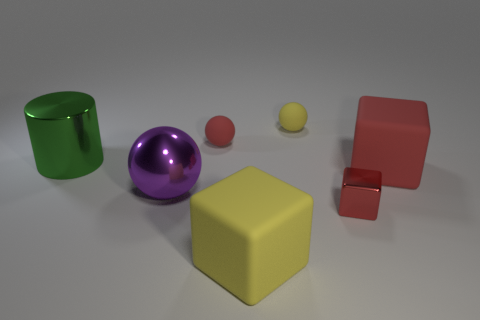There is a cube that is the same material as the big red object; what is its size?
Keep it short and to the point. Large. Is the big yellow cube made of the same material as the small red cube?
Your answer should be compact. No. What number of other objects are there of the same material as the small red block?
Offer a very short reply. 2. How many spheres are on the right side of the purple metallic thing and in front of the red rubber sphere?
Provide a succinct answer. 0. What is the color of the metal ball?
Your response must be concise. Purple. There is a yellow thing that is the same shape as the large purple metal object; what material is it?
Offer a very short reply. Rubber. Is there any other thing that is made of the same material as the tiny red block?
Ensure brevity in your answer.  Yes. Does the shiny cylinder have the same color as the large metal ball?
Make the answer very short. No. The yellow object in front of the matte ball on the left side of the yellow block is what shape?
Provide a short and direct response. Cube. There is a small red thing that is the same material as the large ball; what is its shape?
Give a very brief answer. Cube. 